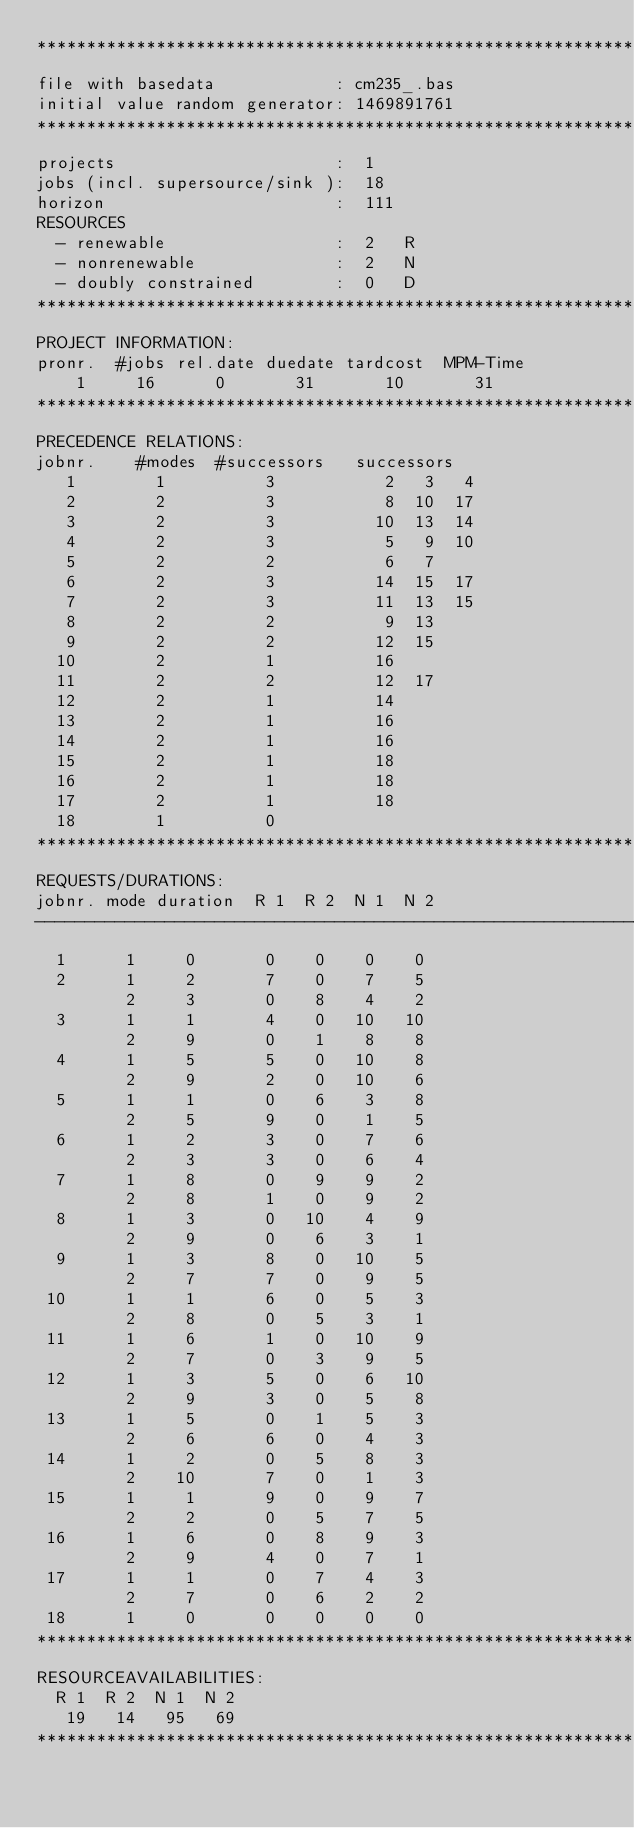<code> <loc_0><loc_0><loc_500><loc_500><_ObjectiveC_>************************************************************************
file with basedata            : cm235_.bas
initial value random generator: 1469891761
************************************************************************
projects                      :  1
jobs (incl. supersource/sink ):  18
horizon                       :  111
RESOURCES
  - renewable                 :  2   R
  - nonrenewable              :  2   N
  - doubly constrained        :  0   D
************************************************************************
PROJECT INFORMATION:
pronr.  #jobs rel.date duedate tardcost  MPM-Time
    1     16      0       31       10       31
************************************************************************
PRECEDENCE RELATIONS:
jobnr.    #modes  #successors   successors
   1        1          3           2   3   4
   2        2          3           8  10  17
   3        2          3          10  13  14
   4        2          3           5   9  10
   5        2          2           6   7
   6        2          3          14  15  17
   7        2          3          11  13  15
   8        2          2           9  13
   9        2          2          12  15
  10        2          1          16
  11        2          2          12  17
  12        2          1          14
  13        2          1          16
  14        2          1          16
  15        2          1          18
  16        2          1          18
  17        2          1          18
  18        1          0        
************************************************************************
REQUESTS/DURATIONS:
jobnr. mode duration  R 1  R 2  N 1  N 2
------------------------------------------------------------------------
  1      1     0       0    0    0    0
  2      1     2       7    0    7    5
         2     3       0    8    4    2
  3      1     1       4    0   10   10
         2     9       0    1    8    8
  4      1     5       5    0   10    8
         2     9       2    0   10    6
  5      1     1       0    6    3    8
         2     5       9    0    1    5
  6      1     2       3    0    7    6
         2     3       3    0    6    4
  7      1     8       0    9    9    2
         2     8       1    0    9    2
  8      1     3       0   10    4    9
         2     9       0    6    3    1
  9      1     3       8    0   10    5
         2     7       7    0    9    5
 10      1     1       6    0    5    3
         2     8       0    5    3    1
 11      1     6       1    0   10    9
         2     7       0    3    9    5
 12      1     3       5    0    6   10
         2     9       3    0    5    8
 13      1     5       0    1    5    3
         2     6       6    0    4    3
 14      1     2       0    5    8    3
         2    10       7    0    1    3
 15      1     1       9    0    9    7
         2     2       0    5    7    5
 16      1     6       0    8    9    3
         2     9       4    0    7    1
 17      1     1       0    7    4    3
         2     7       0    6    2    2
 18      1     0       0    0    0    0
************************************************************************
RESOURCEAVAILABILITIES:
  R 1  R 2  N 1  N 2
   19   14   95   69
************************************************************************
</code> 